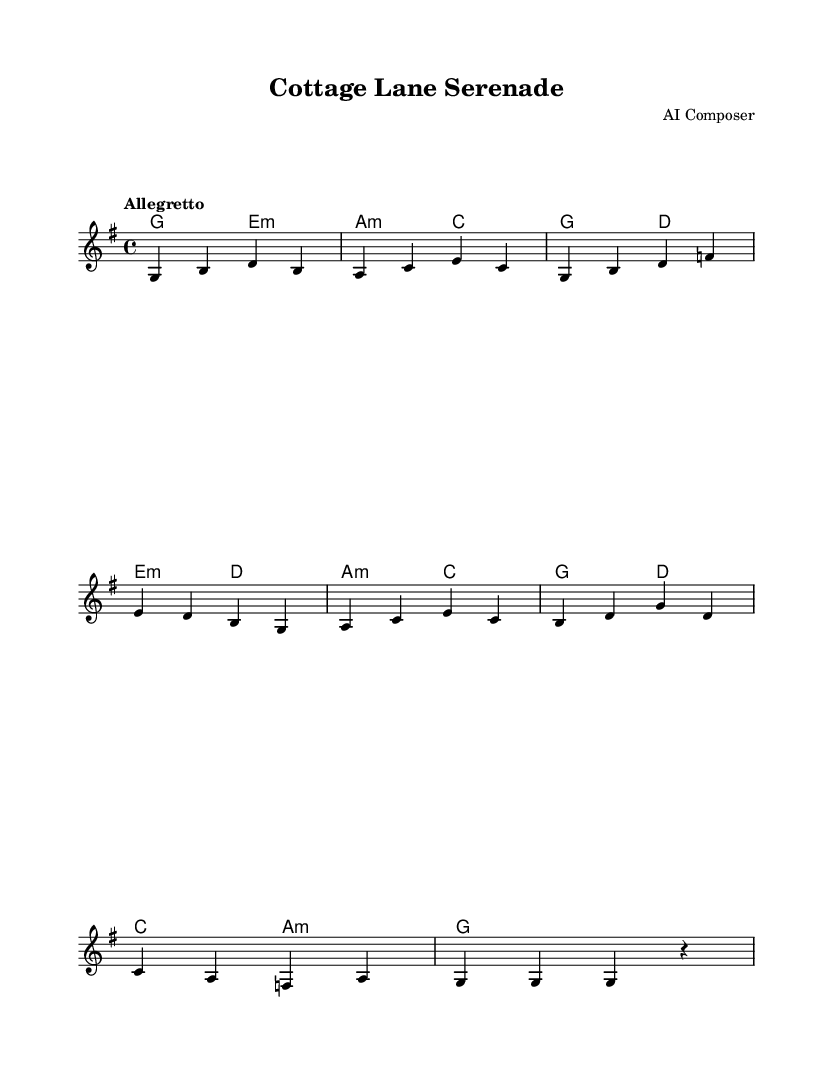What is the key signature of this music? The key signature indicated is G major, which contains one sharp (F#). This is determined by the key signature marking at the beginning of the sheet music.
Answer: G major What is the time signature of this music? The time signature is 4/4, as shown at the beginning of the score. This means there are four beats in each measure, and the quarter note gets one beat.
Answer: 4/4 What is the tempo marking for this piece? The tempo marking is "Allegretto," which indicates a moderate tempo. This is found in the tempo marking section at the start of the score.
Answer: Allegretto How many measures are in the melody? The melody consists of 8 measures in total, as counted from the beginning to the end of the melodic line in the score.
Answer: 8 What is the last chord in the harmonies section? The last chord is G major, indicated by "g1," meaning the chord is to be held for the entire measure. This can be found in the harmonies section at the end of the score.
Answer: G major What is the first note of the melody? The first note of the melody is G, which can be identified by looking at the very first note in the melodic staff.
Answer: G How many different chords are used in the harmonies? There are 6 different chords used in the harmonies: G, E minor, A minor, C, D, and A minor. Each chord can be found in the chord mode section across the score.
Answer: 6 